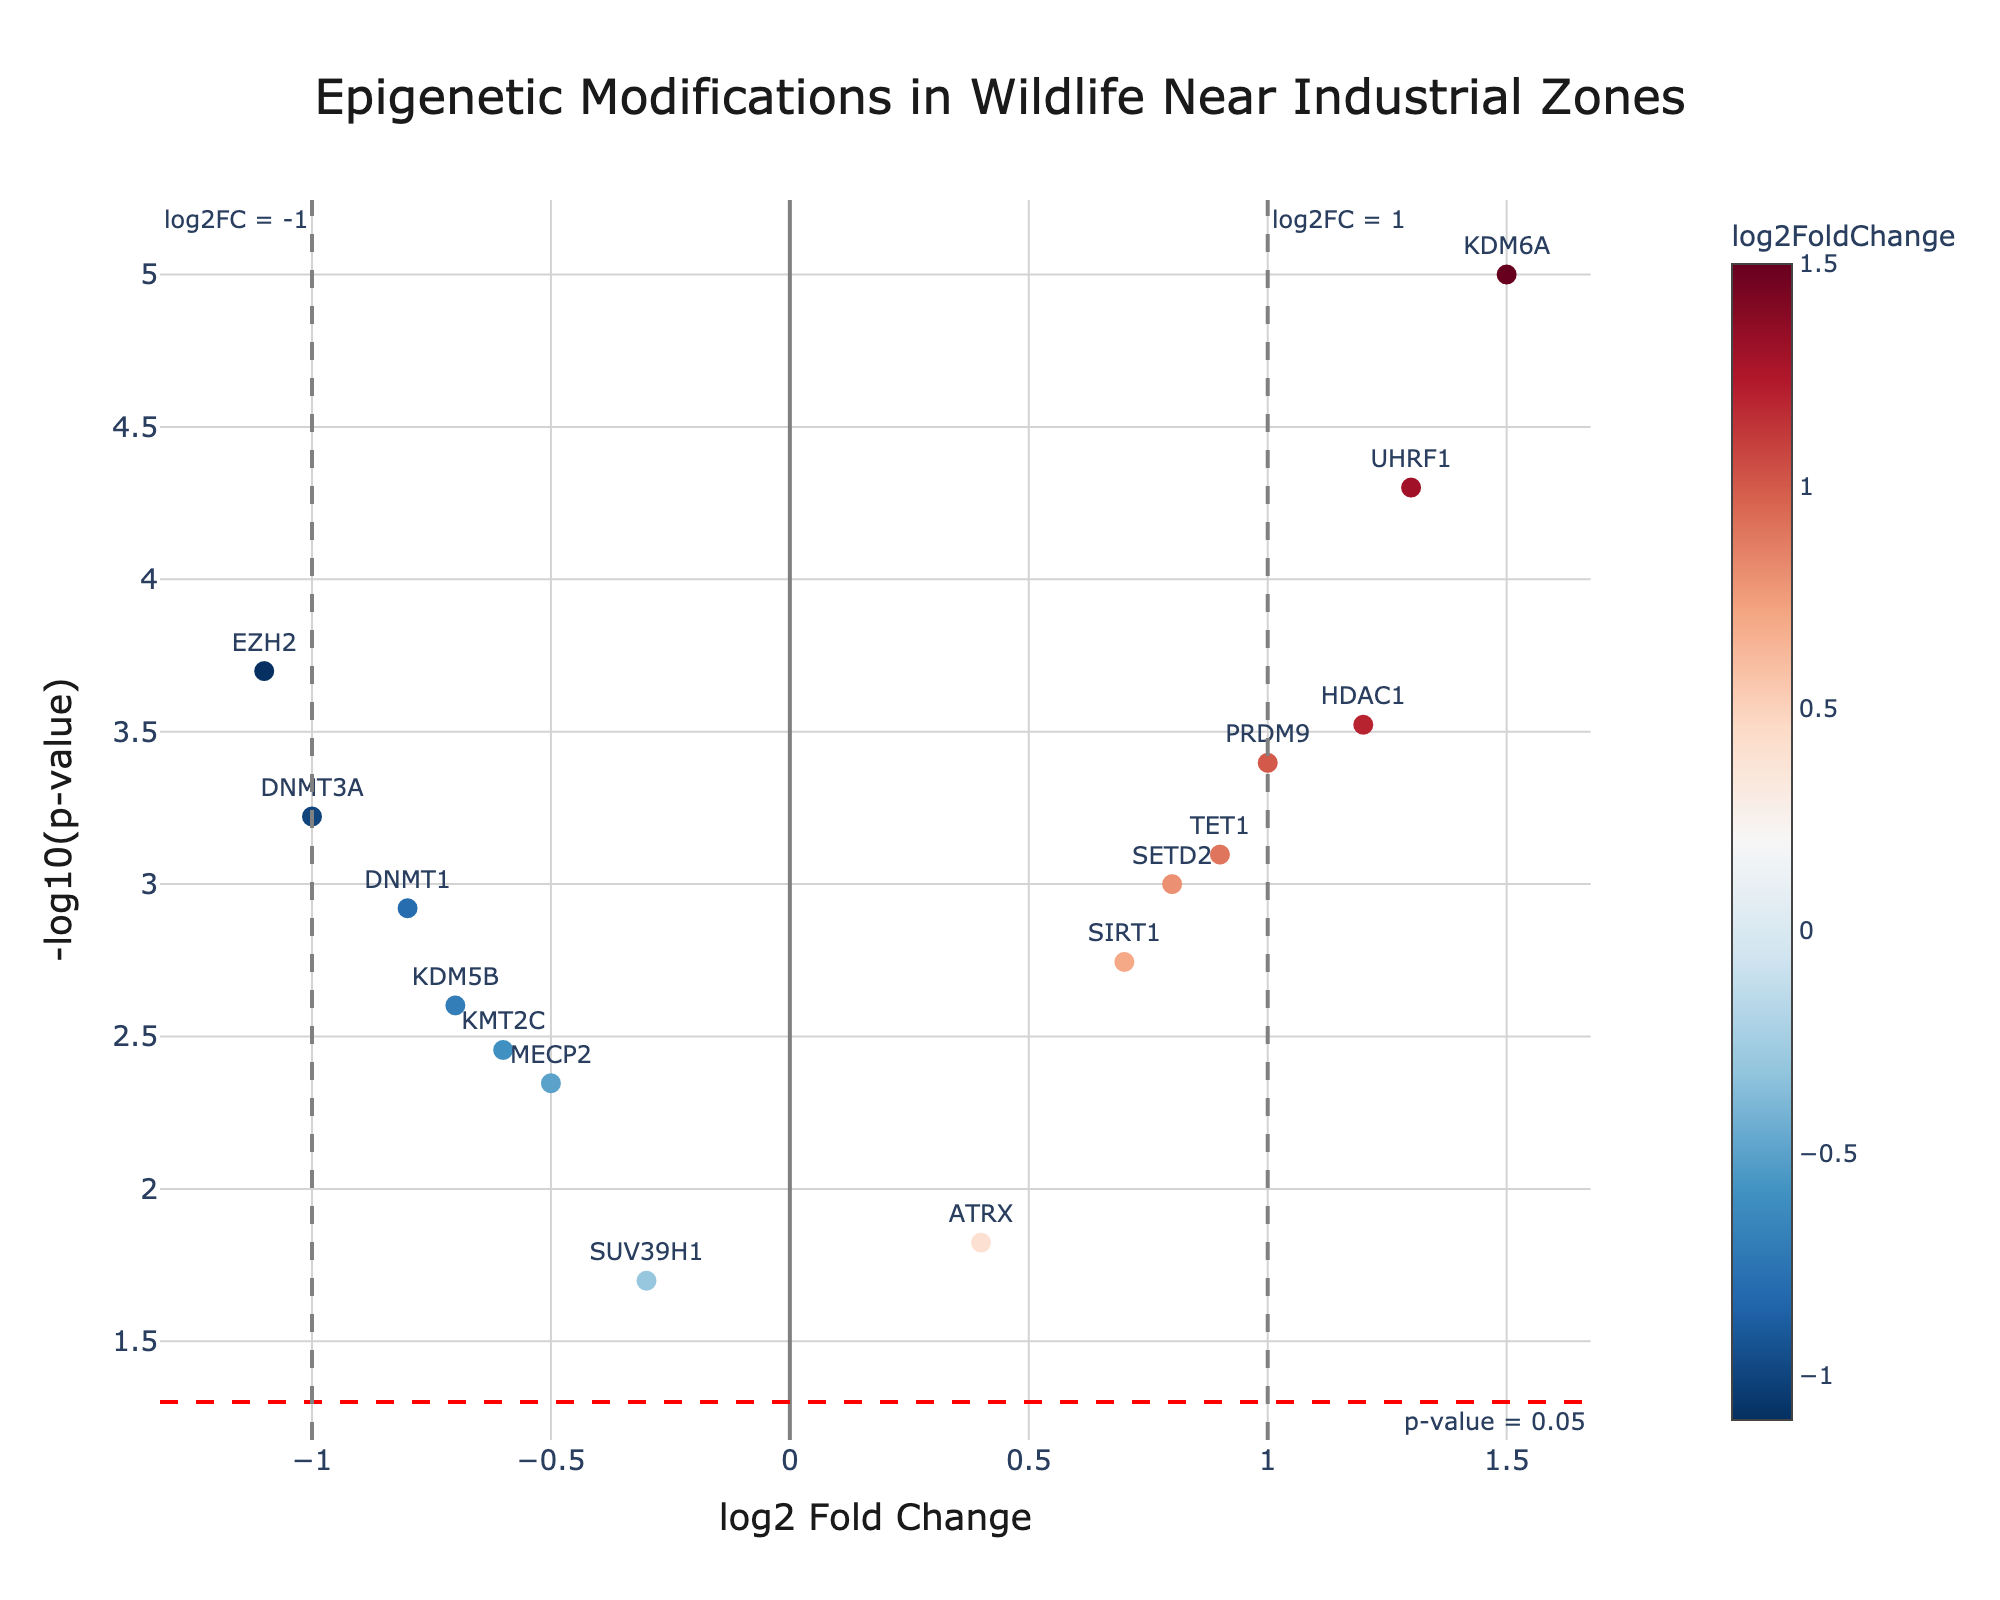What is the title of the plot? The title of the plot is usually displayed at the top center or top of the figure. Here, it can be found as "Epigenetic Modifications in Wildlife Near Industrial Zones".
Answer: Epigenetic Modifications in Wildlife Near Industrial Zones What do the x-axis and y-axis represent in this plot? The x-axis represents the log2 Fold Change, indicating the change in gene expression levels, while the y-axis represents the -log10 of p-value, indicating the significance of these changes.
Answer: x-axis: log2 Fold Change, y-axis: -log10(p-value) Which gene shows the highest log2 Fold Change? By examining the plot, identify the data point that has the highest value on the x-axis. "KDM6A" has the highest log2 Fold Change at 1.5.
Answer: KDM6A How many genes have a p-value less than 0.05 but a log2 Fold Change between -1 and 1? First, check the horizontal dashed line representing a p-value of 0.05. Then, count the data points between -1 and 1 on the x-axis and above this line. Five genes fit this criterion: ATRX, SETD2, SIRT1, TET1, and MECP2.
Answer: 5 genes Which gene is the most statistically significant? The most statistically significant gene will be the gene with the highest -log10(p-value) on the y-axis. Here, "KDM6A" has the highest y-axis value indicating the smallest p-value.
Answer: KDM6A Between DNMT3A and UHRF1, which gene has a stronger fold change and how can you tell? Compare the x-axis values for both genes. DNMT3A has a log2 Fold Change of -1.0 while UHRF1 has a log2 Fold Change of 1.3. Since 1.3 is farther from zero than -1.0, UHRF1 has a stronger fold change.
Answer: UHRF1 Are there more genes with negative or positive log2 Fold Change? Count the data points on either side of the center vertical line (log2FC = 0). There are 7 genes with negative log2 Fold Change and 8 with positive log2 Fold Change. Therefore, there are more genes with positive log2 Fold Change.
Answer: More positive Why are threshold lines drawn on the plot? Threshold lines such as those at y=-log10(0.05) and x=±1 help distinguish significantly changed genes (statistically and fold-change-wise). They provide visual cutoffs to highlight important regions in the plot.
Answer: To highlight significance How would the classifications of genes be different if the log2 Fold Change threshold were set to ±1.5 instead of ±1.0? If the threshold changes to ±1.5, only genes with log2 Fold Change values of ≤-1.5 or ≥1.5 are considered high fold change. This leaves fewer genes meeting the criterion: only "KDM6A" and "UHRF1" would fall into this redefined category.
Answer: Fewer genes would meet the new criterion 